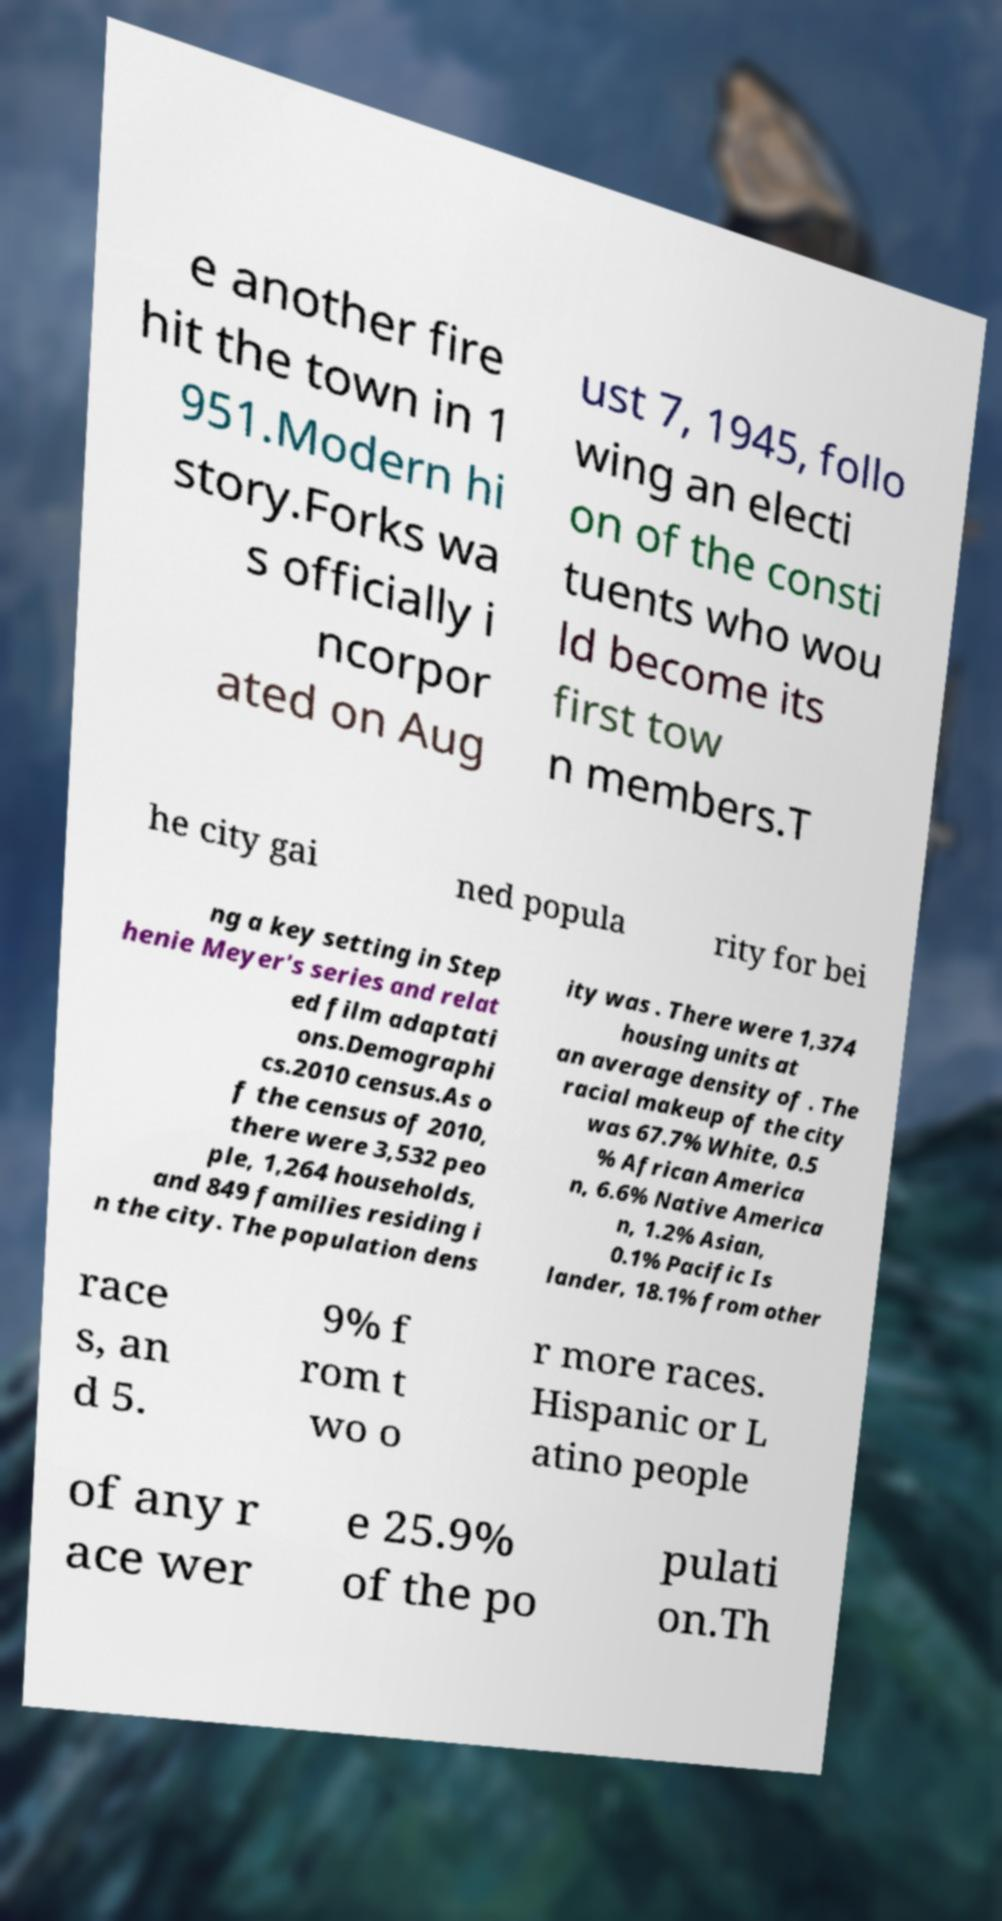Please read and relay the text visible in this image. What does it say? e another fire hit the town in 1 951.Modern hi story.Forks wa s officially i ncorpor ated on Aug ust 7, 1945, follo wing an electi on of the consti tuents who wou ld become its first tow n members.T he city gai ned popula rity for bei ng a key setting in Step henie Meyer's series and relat ed film adaptati ons.Demographi cs.2010 census.As o f the census of 2010, there were 3,532 peo ple, 1,264 households, and 849 families residing i n the city. The population dens ity was . There were 1,374 housing units at an average density of . The racial makeup of the city was 67.7% White, 0.5 % African America n, 6.6% Native America n, 1.2% Asian, 0.1% Pacific Is lander, 18.1% from other race s, an d 5. 9% f rom t wo o r more races. Hispanic or L atino people of any r ace wer e 25.9% of the po pulati on.Th 